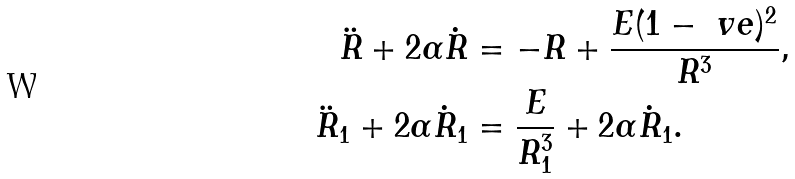Convert formula to latex. <formula><loc_0><loc_0><loc_500><loc_500>\ddot { R } + 2 \alpha \dot { R } & = - R + \frac { E ( 1 - \ v e ) ^ { 2 } } { R ^ { 3 } } , \\ \ddot { R } _ { 1 } + 2 \alpha \dot { R } _ { 1 } & = \frac { E } { R _ { 1 } ^ { 3 } } + 2 \alpha \dot { R } _ { 1 } .</formula> 